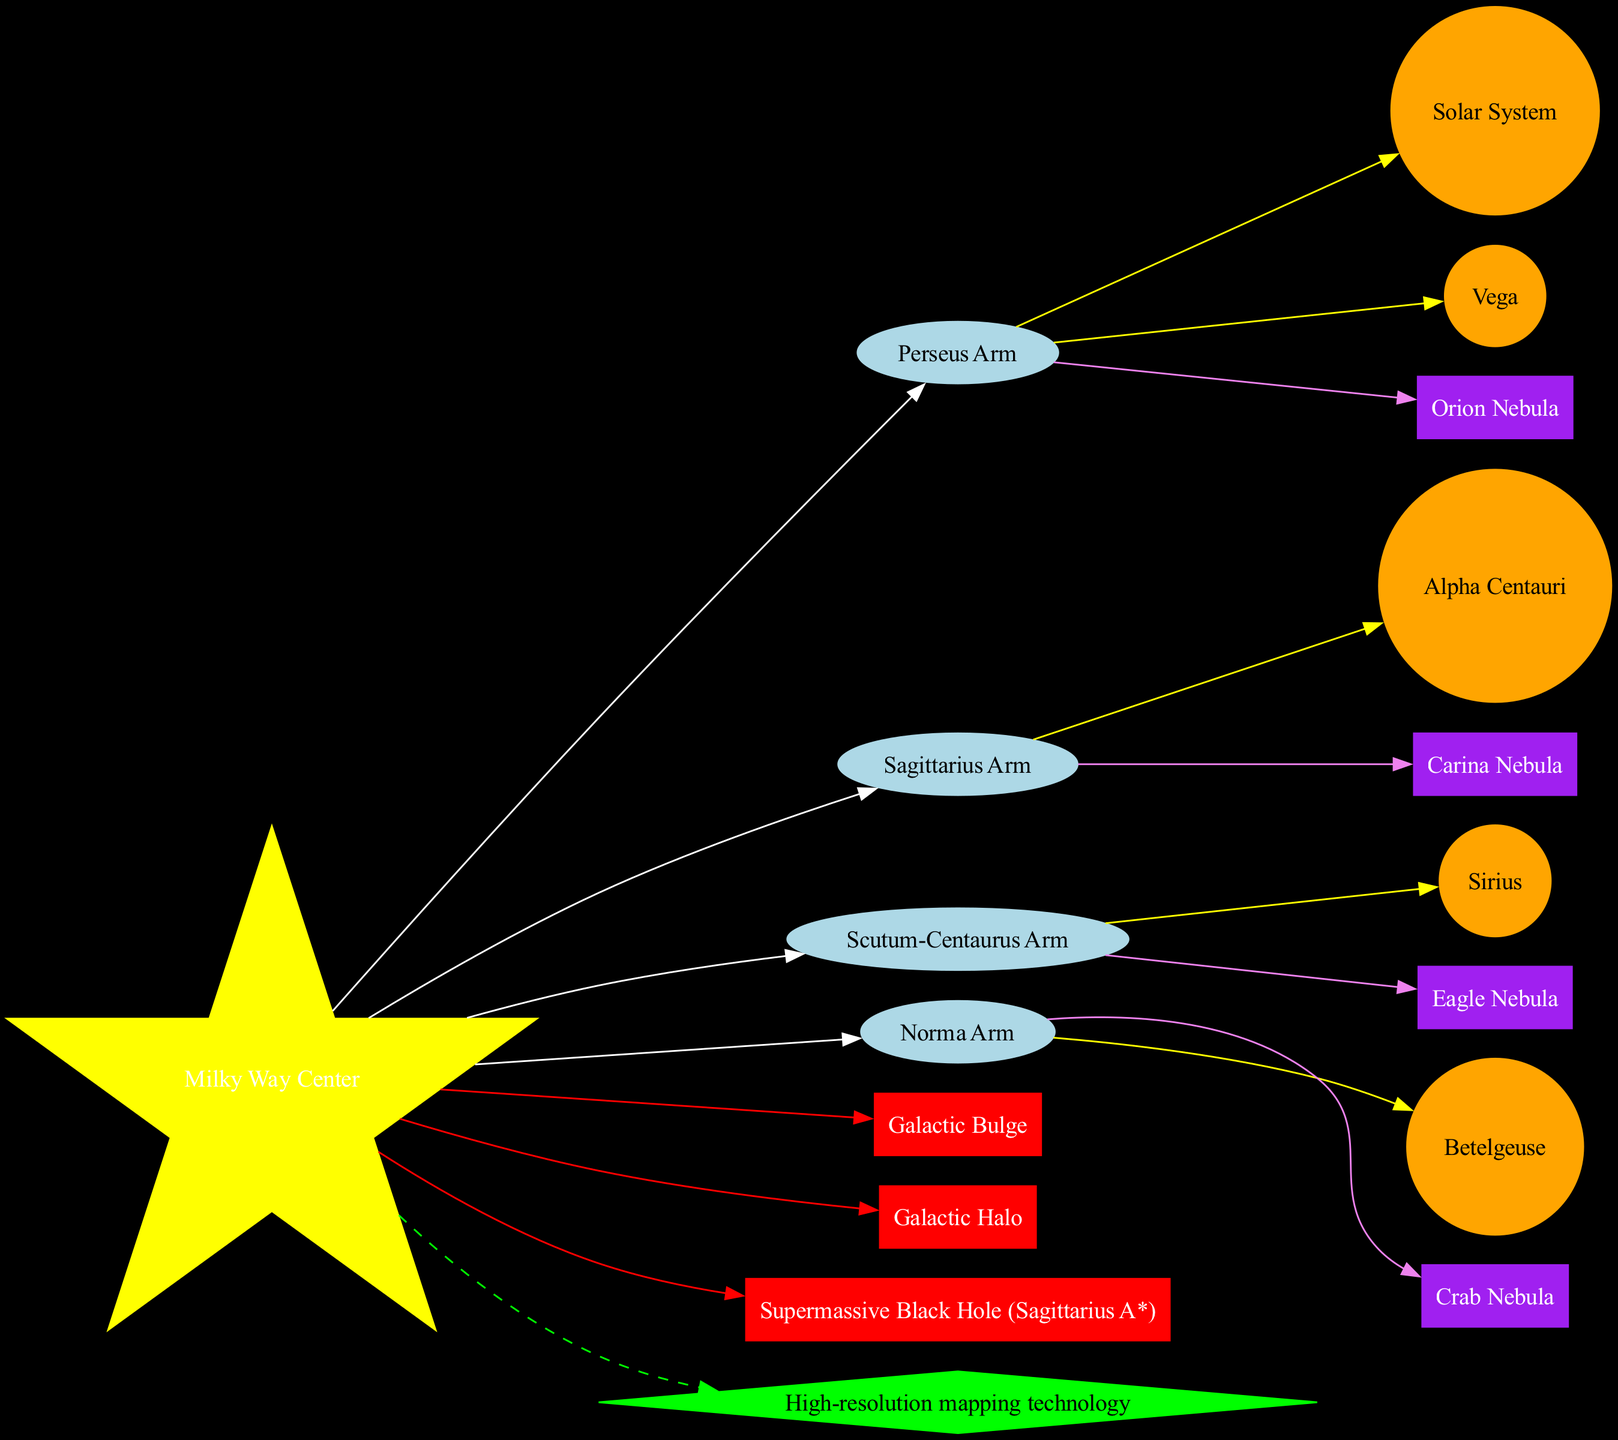What is the center of the Milky Way galaxy? The diagram indicates the center of the Milky Way galaxy as "Milky Way Center" located at the central node.
Answer: Milky Way Center How many major star systems are highlighted in the diagram? The diagram lists five major star systems: Solar System, Alpha Centauri, Sirius, Betelgeuse, and Vega. Therefore, adding them gives a total of five systems.
Answer: 5 Which arm is closest to the Solar System? The Solar System is connected to the nearest arm in the diagram, which can be identified as the "Sagittarius Arm." This is found by tracing the edge that connects the Solar System to the arms.
Answer: Sagittarius Arm What color represents notable nebulae in the diagram? Notable nebulae are represented with the cloud shape in the diagram, which is colored purple, as indicated in the node attributes.
Answer: Purple Which key feature is linked to the center of the galaxy with a red edge? In the diagram, the "Supermassive Black Hole (Sagittarius A*)" is connected to the center node with a red edge, indicating its importance as a key feature.
Answer: Supermassive Black Hole (Sagittarius A*) Which star system is connected to the Perseus Arm? Upon reviewing the connections, the star system "Sirius" is directly linked to the Perseus Arm in the diagram, based on its position relative to the arms provided.
Answer: Sirius How many arms are there in the Milky Way galaxy map? There are four distinct arms illustrated: Perseus Arm, Sagittarius Arm, Scutum-Centaurus Arm, and Norma Arm, thus accounting for a total of four arms.
Answer: 4 What is the competitive advantage mentioned in the diagram? The diagram outlines "High-resolution mapping technology" as the competitive advantage, which is linked via a dashed edge to the center node, emphasizing its significance.
Answer: High-resolution mapping technology 